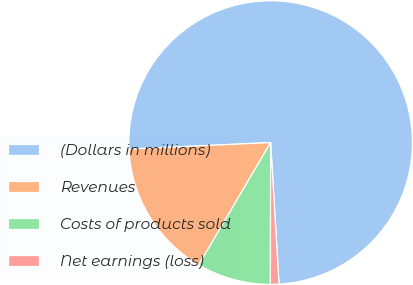<chart> <loc_0><loc_0><loc_500><loc_500><pie_chart><fcel>(Dollars in millions)<fcel>Revenues<fcel>Costs of products sold<fcel>Net earnings (loss)<nl><fcel>74.78%<fcel>15.81%<fcel>8.43%<fcel>0.97%<nl></chart> 